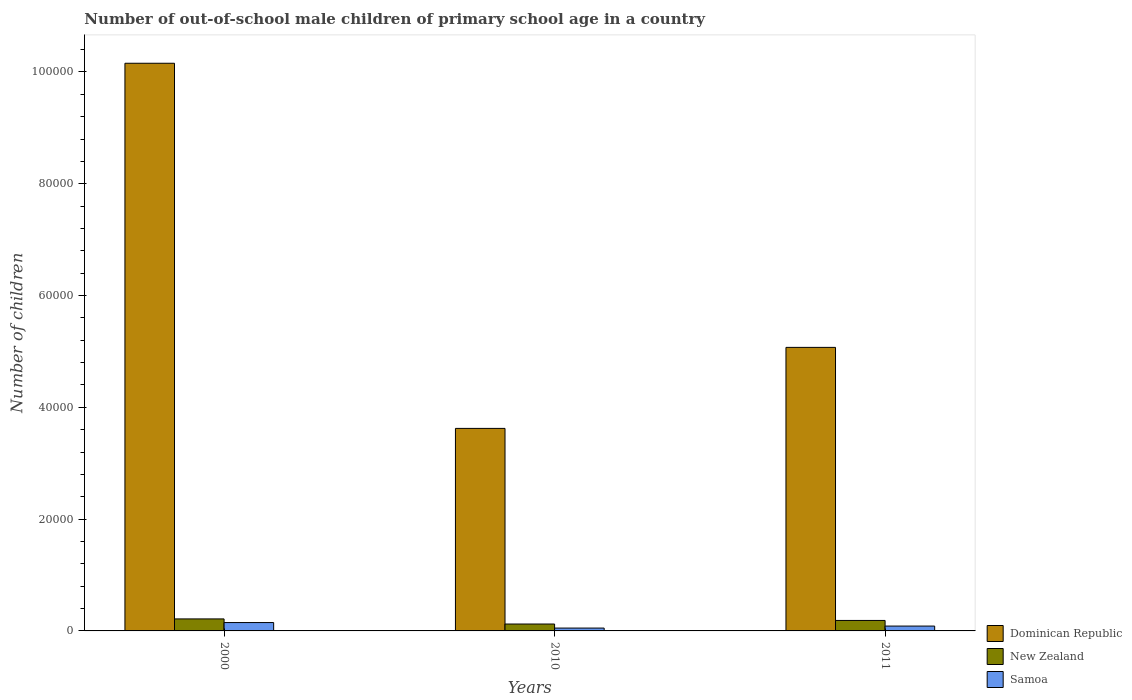How many different coloured bars are there?
Offer a very short reply. 3. How many groups of bars are there?
Make the answer very short. 3. Are the number of bars per tick equal to the number of legend labels?
Ensure brevity in your answer.  Yes. Are the number of bars on each tick of the X-axis equal?
Provide a succinct answer. Yes. How many bars are there on the 1st tick from the left?
Your response must be concise. 3. What is the label of the 3rd group of bars from the left?
Provide a short and direct response. 2011. What is the number of out-of-school male children in Samoa in 2010?
Give a very brief answer. 510. Across all years, what is the maximum number of out-of-school male children in Dominican Republic?
Make the answer very short. 1.02e+05. Across all years, what is the minimum number of out-of-school male children in Dominican Republic?
Offer a terse response. 3.62e+04. In which year was the number of out-of-school male children in Dominican Republic minimum?
Ensure brevity in your answer.  2010. What is the total number of out-of-school male children in Dominican Republic in the graph?
Provide a succinct answer. 1.89e+05. What is the difference between the number of out-of-school male children in Samoa in 2000 and that in 2011?
Provide a short and direct response. 628. What is the difference between the number of out-of-school male children in Dominican Republic in 2000 and the number of out-of-school male children in New Zealand in 2011?
Provide a short and direct response. 9.97e+04. What is the average number of out-of-school male children in New Zealand per year?
Offer a very short reply. 1751.67. In the year 2000, what is the difference between the number of out-of-school male children in New Zealand and number of out-of-school male children in Dominican Republic?
Keep it short and to the point. -9.94e+04. What is the ratio of the number of out-of-school male children in Samoa in 2010 to that in 2011?
Keep it short and to the point. 0.59. Is the difference between the number of out-of-school male children in New Zealand in 2000 and 2010 greater than the difference between the number of out-of-school male children in Dominican Republic in 2000 and 2010?
Offer a very short reply. No. What is the difference between the highest and the second highest number of out-of-school male children in New Zealand?
Make the answer very short. 272. What is the difference between the highest and the lowest number of out-of-school male children in Dominican Republic?
Offer a terse response. 6.53e+04. In how many years, is the number of out-of-school male children in New Zealand greater than the average number of out-of-school male children in New Zealand taken over all years?
Keep it short and to the point. 2. What does the 2nd bar from the left in 2011 represents?
Ensure brevity in your answer.  New Zealand. What does the 1st bar from the right in 2011 represents?
Ensure brevity in your answer.  Samoa. Are all the bars in the graph horizontal?
Make the answer very short. No. Does the graph contain any zero values?
Give a very brief answer. No. Does the graph contain grids?
Make the answer very short. No. What is the title of the graph?
Offer a terse response. Number of out-of-school male children of primary school age in a country. Does "Timor-Leste" appear as one of the legend labels in the graph?
Offer a terse response. No. What is the label or title of the X-axis?
Ensure brevity in your answer.  Years. What is the label or title of the Y-axis?
Offer a terse response. Number of children. What is the Number of children of Dominican Republic in 2000?
Make the answer very short. 1.02e+05. What is the Number of children in New Zealand in 2000?
Give a very brief answer. 2147. What is the Number of children of Samoa in 2000?
Provide a short and direct response. 1496. What is the Number of children in Dominican Republic in 2010?
Offer a terse response. 3.62e+04. What is the Number of children in New Zealand in 2010?
Offer a terse response. 1233. What is the Number of children of Samoa in 2010?
Your response must be concise. 510. What is the Number of children in Dominican Republic in 2011?
Provide a short and direct response. 5.07e+04. What is the Number of children of New Zealand in 2011?
Your answer should be very brief. 1875. What is the Number of children of Samoa in 2011?
Ensure brevity in your answer.  868. Across all years, what is the maximum Number of children of Dominican Republic?
Provide a succinct answer. 1.02e+05. Across all years, what is the maximum Number of children of New Zealand?
Offer a very short reply. 2147. Across all years, what is the maximum Number of children of Samoa?
Your answer should be compact. 1496. Across all years, what is the minimum Number of children in Dominican Republic?
Give a very brief answer. 3.62e+04. Across all years, what is the minimum Number of children of New Zealand?
Your response must be concise. 1233. Across all years, what is the minimum Number of children in Samoa?
Provide a short and direct response. 510. What is the total Number of children of Dominican Republic in the graph?
Ensure brevity in your answer.  1.89e+05. What is the total Number of children in New Zealand in the graph?
Make the answer very short. 5255. What is the total Number of children of Samoa in the graph?
Offer a terse response. 2874. What is the difference between the Number of children in Dominican Republic in 2000 and that in 2010?
Ensure brevity in your answer.  6.53e+04. What is the difference between the Number of children in New Zealand in 2000 and that in 2010?
Offer a very short reply. 914. What is the difference between the Number of children in Samoa in 2000 and that in 2010?
Offer a terse response. 986. What is the difference between the Number of children in Dominican Republic in 2000 and that in 2011?
Provide a succinct answer. 5.08e+04. What is the difference between the Number of children of New Zealand in 2000 and that in 2011?
Ensure brevity in your answer.  272. What is the difference between the Number of children of Samoa in 2000 and that in 2011?
Give a very brief answer. 628. What is the difference between the Number of children of Dominican Republic in 2010 and that in 2011?
Make the answer very short. -1.45e+04. What is the difference between the Number of children in New Zealand in 2010 and that in 2011?
Make the answer very short. -642. What is the difference between the Number of children of Samoa in 2010 and that in 2011?
Make the answer very short. -358. What is the difference between the Number of children of Dominican Republic in 2000 and the Number of children of New Zealand in 2010?
Keep it short and to the point. 1.00e+05. What is the difference between the Number of children in Dominican Republic in 2000 and the Number of children in Samoa in 2010?
Keep it short and to the point. 1.01e+05. What is the difference between the Number of children in New Zealand in 2000 and the Number of children in Samoa in 2010?
Make the answer very short. 1637. What is the difference between the Number of children of Dominican Republic in 2000 and the Number of children of New Zealand in 2011?
Your answer should be very brief. 9.97e+04. What is the difference between the Number of children in Dominican Republic in 2000 and the Number of children in Samoa in 2011?
Offer a very short reply. 1.01e+05. What is the difference between the Number of children in New Zealand in 2000 and the Number of children in Samoa in 2011?
Offer a very short reply. 1279. What is the difference between the Number of children in Dominican Republic in 2010 and the Number of children in New Zealand in 2011?
Ensure brevity in your answer.  3.44e+04. What is the difference between the Number of children of Dominican Republic in 2010 and the Number of children of Samoa in 2011?
Keep it short and to the point. 3.54e+04. What is the difference between the Number of children in New Zealand in 2010 and the Number of children in Samoa in 2011?
Offer a terse response. 365. What is the average Number of children of Dominican Republic per year?
Give a very brief answer. 6.28e+04. What is the average Number of children in New Zealand per year?
Ensure brevity in your answer.  1751.67. What is the average Number of children in Samoa per year?
Give a very brief answer. 958. In the year 2000, what is the difference between the Number of children of Dominican Republic and Number of children of New Zealand?
Provide a succinct answer. 9.94e+04. In the year 2000, what is the difference between the Number of children in Dominican Republic and Number of children in Samoa?
Your answer should be very brief. 1.00e+05. In the year 2000, what is the difference between the Number of children of New Zealand and Number of children of Samoa?
Your answer should be very brief. 651. In the year 2010, what is the difference between the Number of children in Dominican Republic and Number of children in New Zealand?
Your answer should be compact. 3.50e+04. In the year 2010, what is the difference between the Number of children of Dominican Republic and Number of children of Samoa?
Provide a succinct answer. 3.57e+04. In the year 2010, what is the difference between the Number of children in New Zealand and Number of children in Samoa?
Your response must be concise. 723. In the year 2011, what is the difference between the Number of children of Dominican Republic and Number of children of New Zealand?
Provide a short and direct response. 4.88e+04. In the year 2011, what is the difference between the Number of children of Dominican Republic and Number of children of Samoa?
Offer a very short reply. 4.99e+04. In the year 2011, what is the difference between the Number of children of New Zealand and Number of children of Samoa?
Offer a terse response. 1007. What is the ratio of the Number of children in Dominican Republic in 2000 to that in 2010?
Provide a succinct answer. 2.8. What is the ratio of the Number of children of New Zealand in 2000 to that in 2010?
Your answer should be compact. 1.74. What is the ratio of the Number of children in Samoa in 2000 to that in 2010?
Keep it short and to the point. 2.93. What is the ratio of the Number of children in Dominican Republic in 2000 to that in 2011?
Your response must be concise. 2. What is the ratio of the Number of children in New Zealand in 2000 to that in 2011?
Offer a very short reply. 1.15. What is the ratio of the Number of children in Samoa in 2000 to that in 2011?
Provide a succinct answer. 1.72. What is the ratio of the Number of children in Dominican Republic in 2010 to that in 2011?
Provide a succinct answer. 0.71. What is the ratio of the Number of children in New Zealand in 2010 to that in 2011?
Offer a terse response. 0.66. What is the ratio of the Number of children of Samoa in 2010 to that in 2011?
Your answer should be compact. 0.59. What is the difference between the highest and the second highest Number of children of Dominican Republic?
Your answer should be very brief. 5.08e+04. What is the difference between the highest and the second highest Number of children of New Zealand?
Your answer should be very brief. 272. What is the difference between the highest and the second highest Number of children in Samoa?
Ensure brevity in your answer.  628. What is the difference between the highest and the lowest Number of children in Dominican Republic?
Offer a terse response. 6.53e+04. What is the difference between the highest and the lowest Number of children in New Zealand?
Keep it short and to the point. 914. What is the difference between the highest and the lowest Number of children in Samoa?
Make the answer very short. 986. 